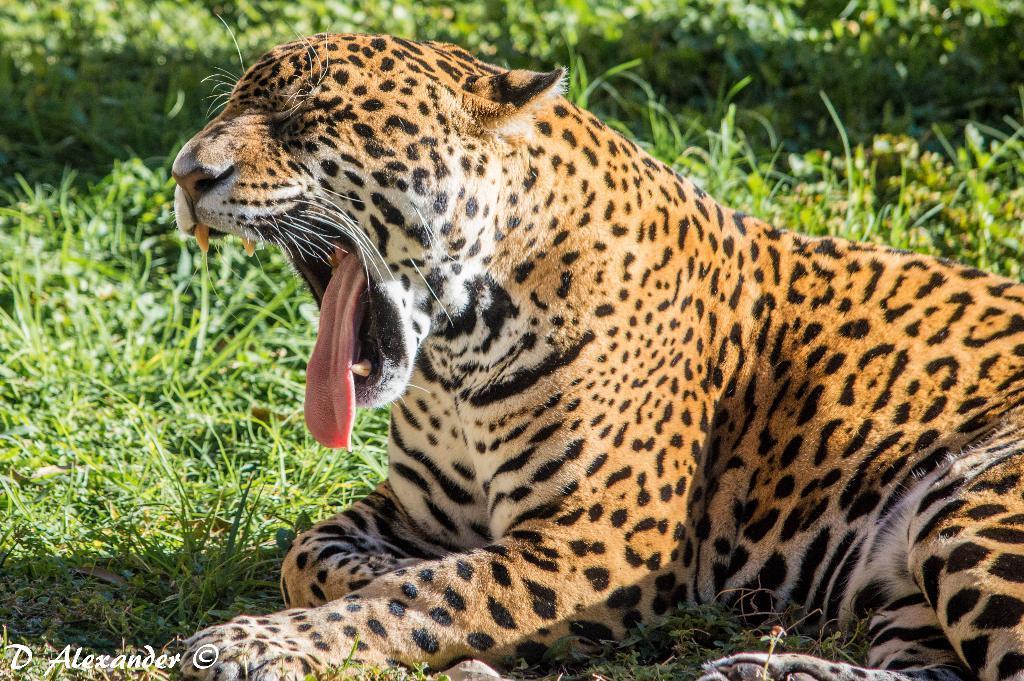In one or two sentences, can you explain what this image depicts? In the image there is a jaguar yawning sitting on grass field. 